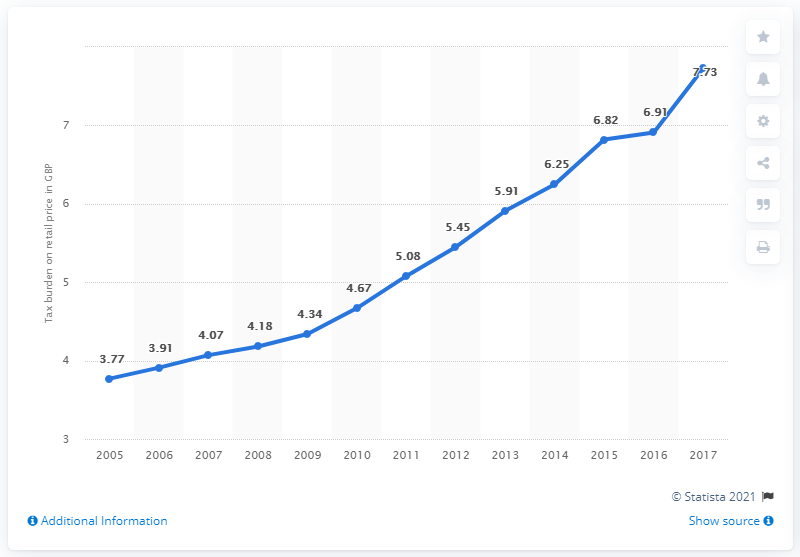Indicate a few pertinent items in this graphic. The average retail tax burden for the years 2005, 2006, and 2007 was 3.91666666666666666666666666666666666666666666666666666666666666666666666666666666666666666666666666666666666666666666666666666666666666666666666666666666666666666666666666666666666666666666666666666666666666666666666666666666666666666666666666666666666666666666666666666666666666666666666666666666666666666666666666666666666666666666666666666666666666666666666666666666666666666666666666666666666666666666666666666666666666666666666666666666666666666666666666666666666666666666666666666666666666666666666666666666666666666666666666666666666666666666666666666666666666666666666666666666666666666666666666666666666666666666666666666666666666666666666666666666666666666666666666666666666666666666666666666666666666666666666666666666666666666666666666666666666666666666666666666666666666666666666666666666666666666666666666666666666666666666666666666666666666666666666666666666666666666666666666666666666666666666666666666666666666666666666666666666666666666666666666666666666666666666666666666666 The value for 2015 is 6.82. 